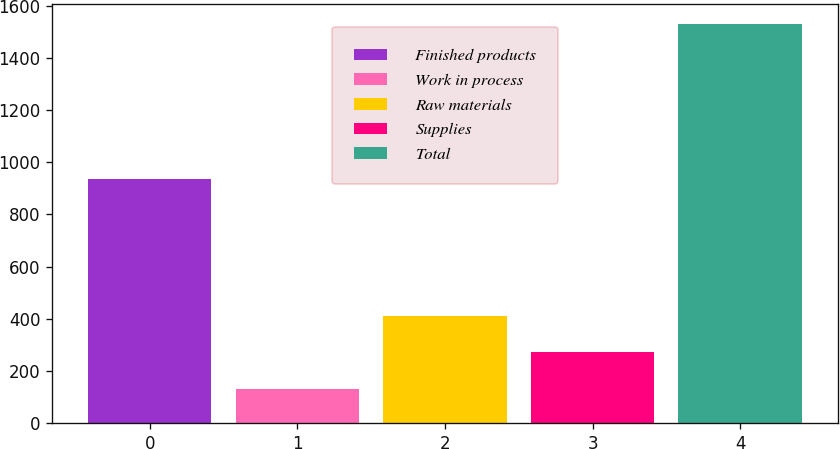Convert chart. <chart><loc_0><loc_0><loc_500><loc_500><bar_chart><fcel>Finished products<fcel>Work in process<fcel>Raw materials<fcel>Supplies<fcel>Total<nl><fcel>937<fcel>131<fcel>411.2<fcel>271.1<fcel>1532<nl></chart> 